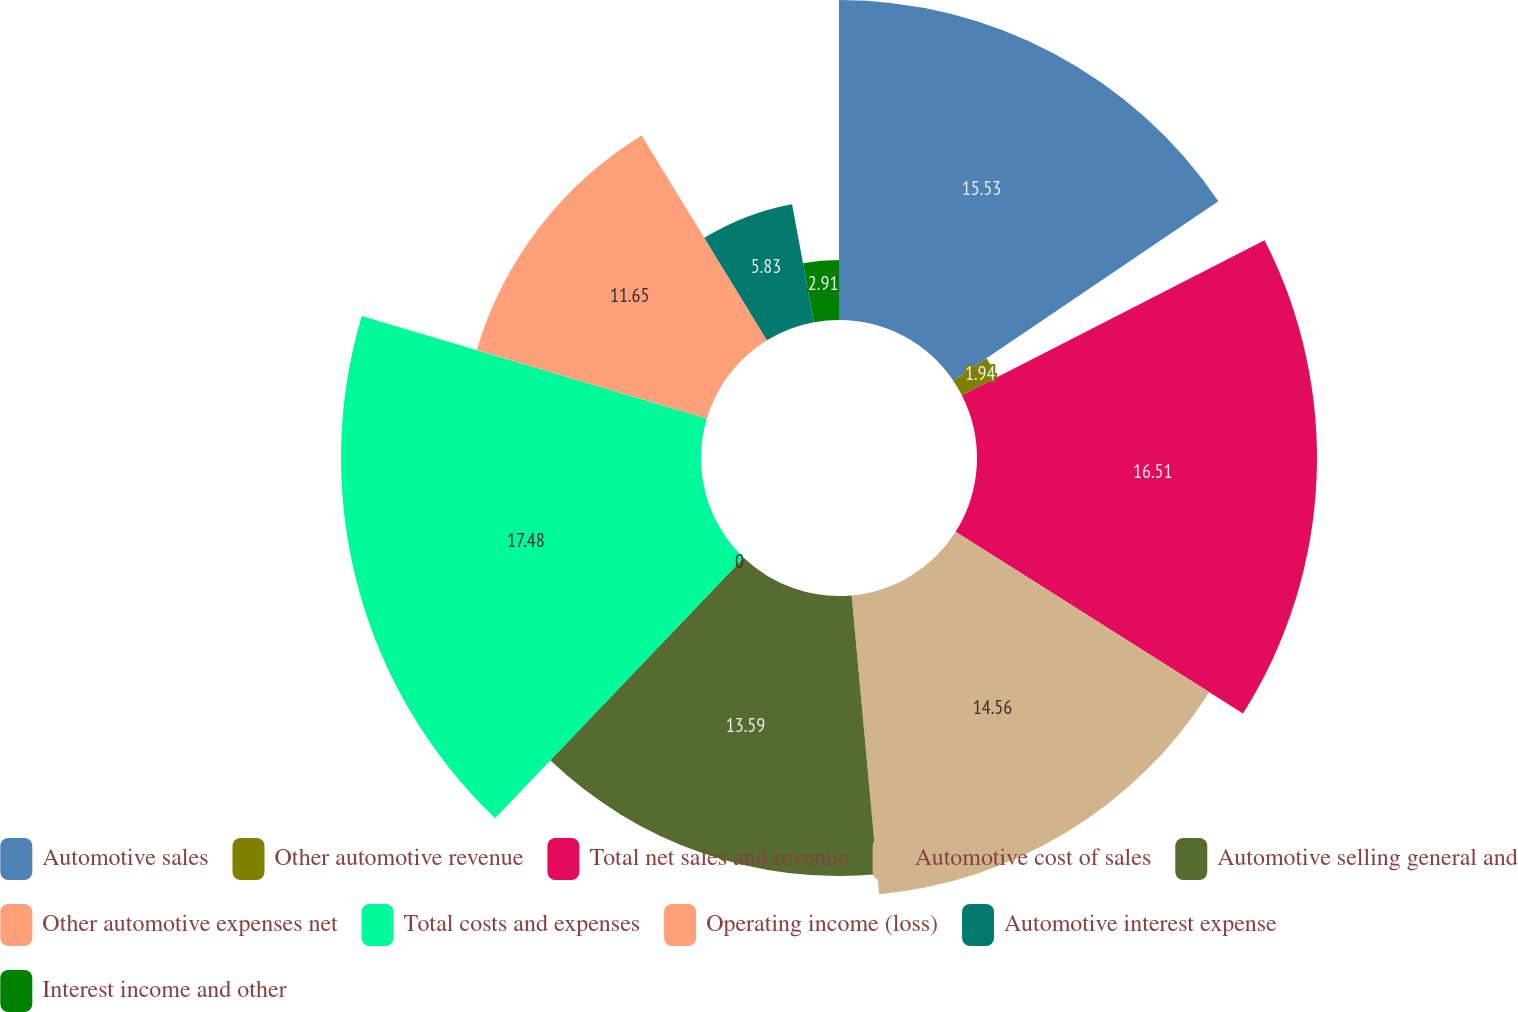<chart> <loc_0><loc_0><loc_500><loc_500><pie_chart><fcel>Automotive sales<fcel>Other automotive revenue<fcel>Total net sales and revenue<fcel>Automotive cost of sales<fcel>Automotive selling general and<fcel>Other automotive expenses net<fcel>Total costs and expenses<fcel>Operating income (loss)<fcel>Automotive interest expense<fcel>Interest income and other<nl><fcel>15.53%<fcel>1.94%<fcel>16.5%<fcel>14.56%<fcel>13.59%<fcel>0.0%<fcel>17.47%<fcel>11.65%<fcel>5.83%<fcel>2.91%<nl></chart> 